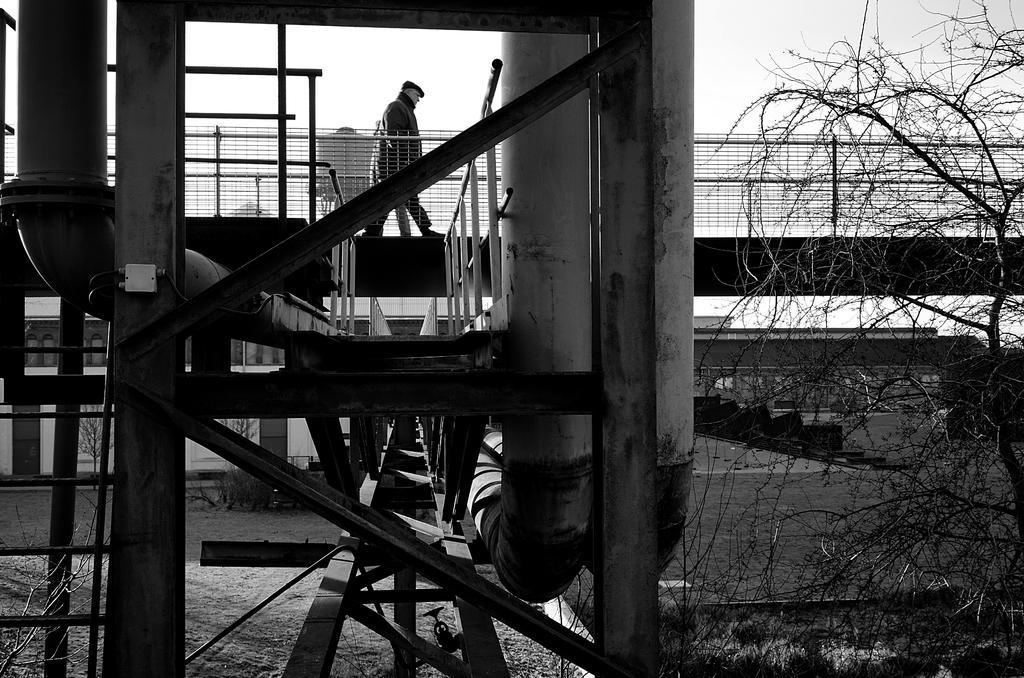Describe this image in one or two sentences. In this picture we can see a bridge,on this bridge there is a person and in the background we can see trees,sky. 